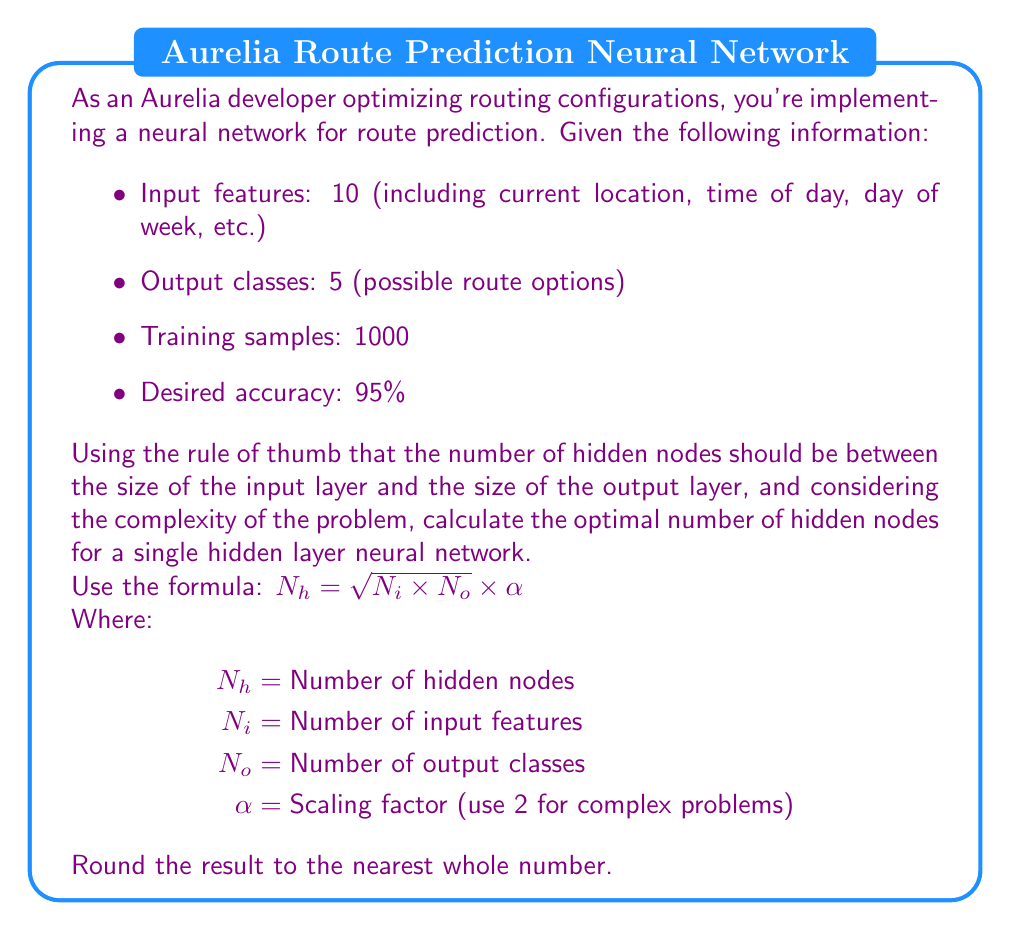Can you answer this question? Let's approach this step-by-step:

1) We're given:
   $N_i$ = 10 (input features)
   $N_o$ = 5 (output classes)
   $\alpha$ = 2 (scaling factor for complex problems)

2) We'll use the formula: $N_h = \sqrt{N_i \times N_o} \times \alpha$

3) First, let's calculate $N_i \times N_o$:
   $10 \times 5 = 50$

4) Now, let's take the square root:
   $\sqrt{50} \approx 7.071$

5) Finally, multiply by the scaling factor $\alpha$:
   $7.071 \times 2 \approx 14.142$

6) Rounding to the nearest whole number:
   $14.142 \approx 14$

Therefore, the optimal number of hidden nodes for this neural network is 14.

This number of hidden nodes should provide a good balance between the network's ability to learn complex patterns (given the number of input features and output classes) and its ability to generalize well to new data, which is crucial for accurate route prediction in an Aurelia routing configuration.
Answer: 14 hidden nodes 